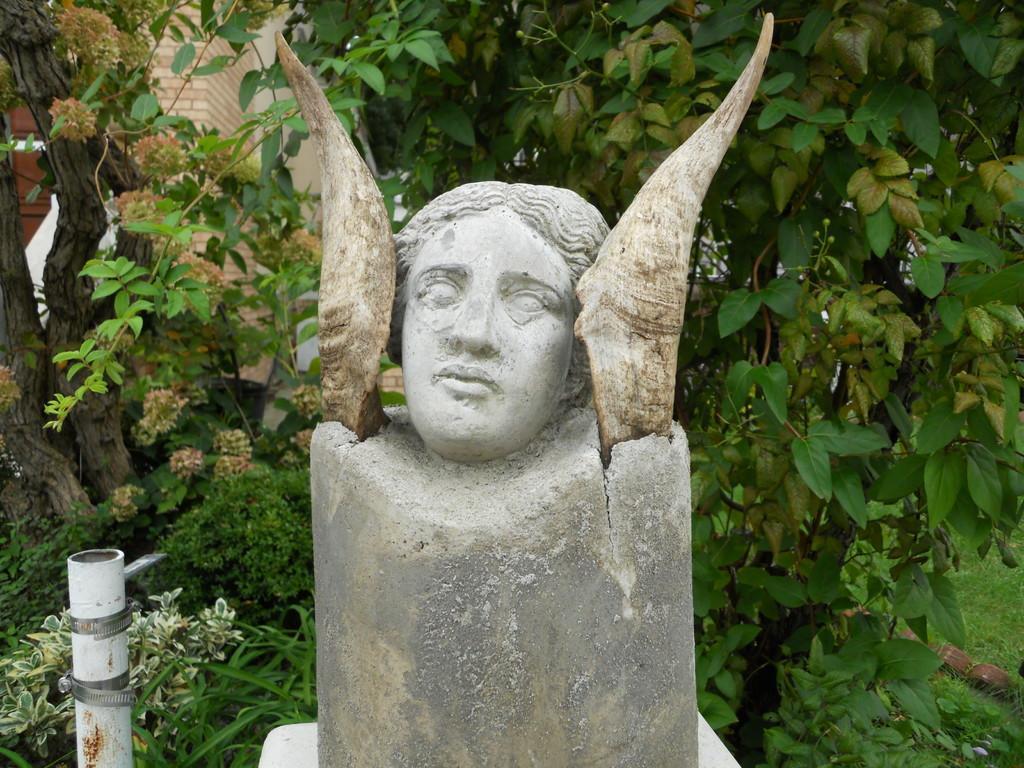Could you give a brief overview of what you see in this image? This picture is taken from outside of the city. In this image, in the middle, we can see a statue. On the left side, we can see a pole. In the background, we can see some trees, plants, flowers and a brick wall. 